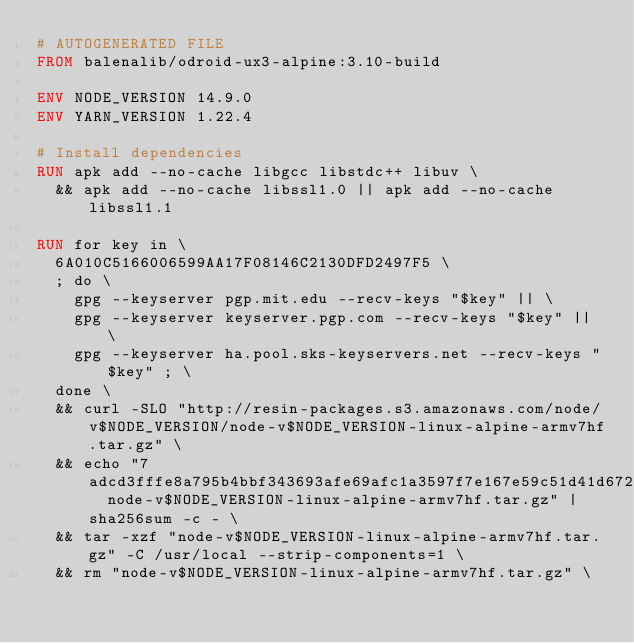<code> <loc_0><loc_0><loc_500><loc_500><_Dockerfile_># AUTOGENERATED FILE
FROM balenalib/odroid-ux3-alpine:3.10-build

ENV NODE_VERSION 14.9.0
ENV YARN_VERSION 1.22.4

# Install dependencies
RUN apk add --no-cache libgcc libstdc++ libuv \
	&& apk add --no-cache libssl1.0 || apk add --no-cache libssl1.1

RUN for key in \
	6A010C5166006599AA17F08146C2130DFD2497F5 \
	; do \
		gpg --keyserver pgp.mit.edu --recv-keys "$key" || \
		gpg --keyserver keyserver.pgp.com --recv-keys "$key" || \
		gpg --keyserver ha.pool.sks-keyservers.net --recv-keys "$key" ; \
	done \
	&& curl -SLO "http://resin-packages.s3.amazonaws.com/node/v$NODE_VERSION/node-v$NODE_VERSION-linux-alpine-armv7hf.tar.gz" \
	&& echo "7adcd3fffe8a795b4bbf343693afe69afc1a3597f7e167e59c51d41d672056af  node-v$NODE_VERSION-linux-alpine-armv7hf.tar.gz" | sha256sum -c - \
	&& tar -xzf "node-v$NODE_VERSION-linux-alpine-armv7hf.tar.gz" -C /usr/local --strip-components=1 \
	&& rm "node-v$NODE_VERSION-linux-alpine-armv7hf.tar.gz" \</code> 